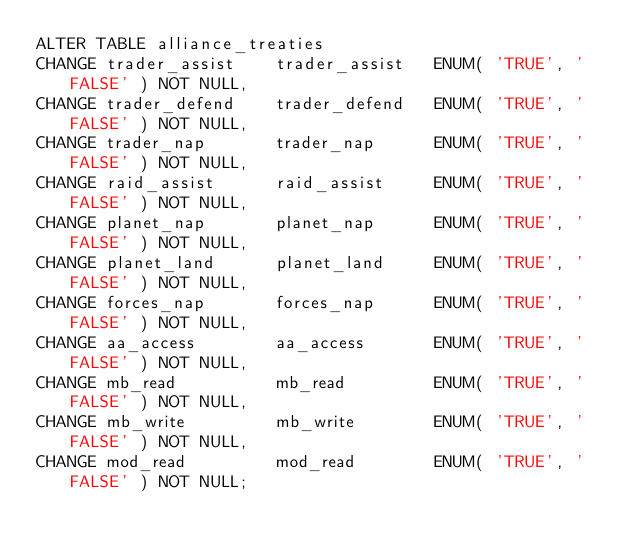Convert code to text. <code><loc_0><loc_0><loc_500><loc_500><_SQL_>ALTER TABLE alliance_treaties
CHANGE trader_assist	trader_assist	ENUM( 'TRUE', 'FALSE' ) NOT NULL,
CHANGE trader_defend	trader_defend	ENUM( 'TRUE', 'FALSE' ) NOT NULL,
CHANGE trader_nap		trader_nap		ENUM( 'TRUE', 'FALSE' ) NOT NULL,
CHANGE raid_assist		raid_assist		ENUM( 'TRUE', 'FALSE' ) NOT NULL,
CHANGE planet_nap		planet_nap		ENUM( 'TRUE', 'FALSE' ) NOT NULL,
CHANGE planet_land		planet_land		ENUM( 'TRUE', 'FALSE' ) NOT NULL,
CHANGE forces_nap		forces_nap		ENUM( 'TRUE', 'FALSE' ) NOT NULL,
CHANGE aa_access		aa_access		ENUM( 'TRUE', 'FALSE' ) NOT NULL,
CHANGE mb_read			mb_read			ENUM( 'TRUE', 'FALSE' ) NOT NULL,
CHANGE mb_write			mb_write		ENUM( 'TRUE', 'FALSE' ) NOT NULL,
CHANGE mod_read			mod_read		ENUM( 'TRUE', 'FALSE' ) NOT NULL;</code> 